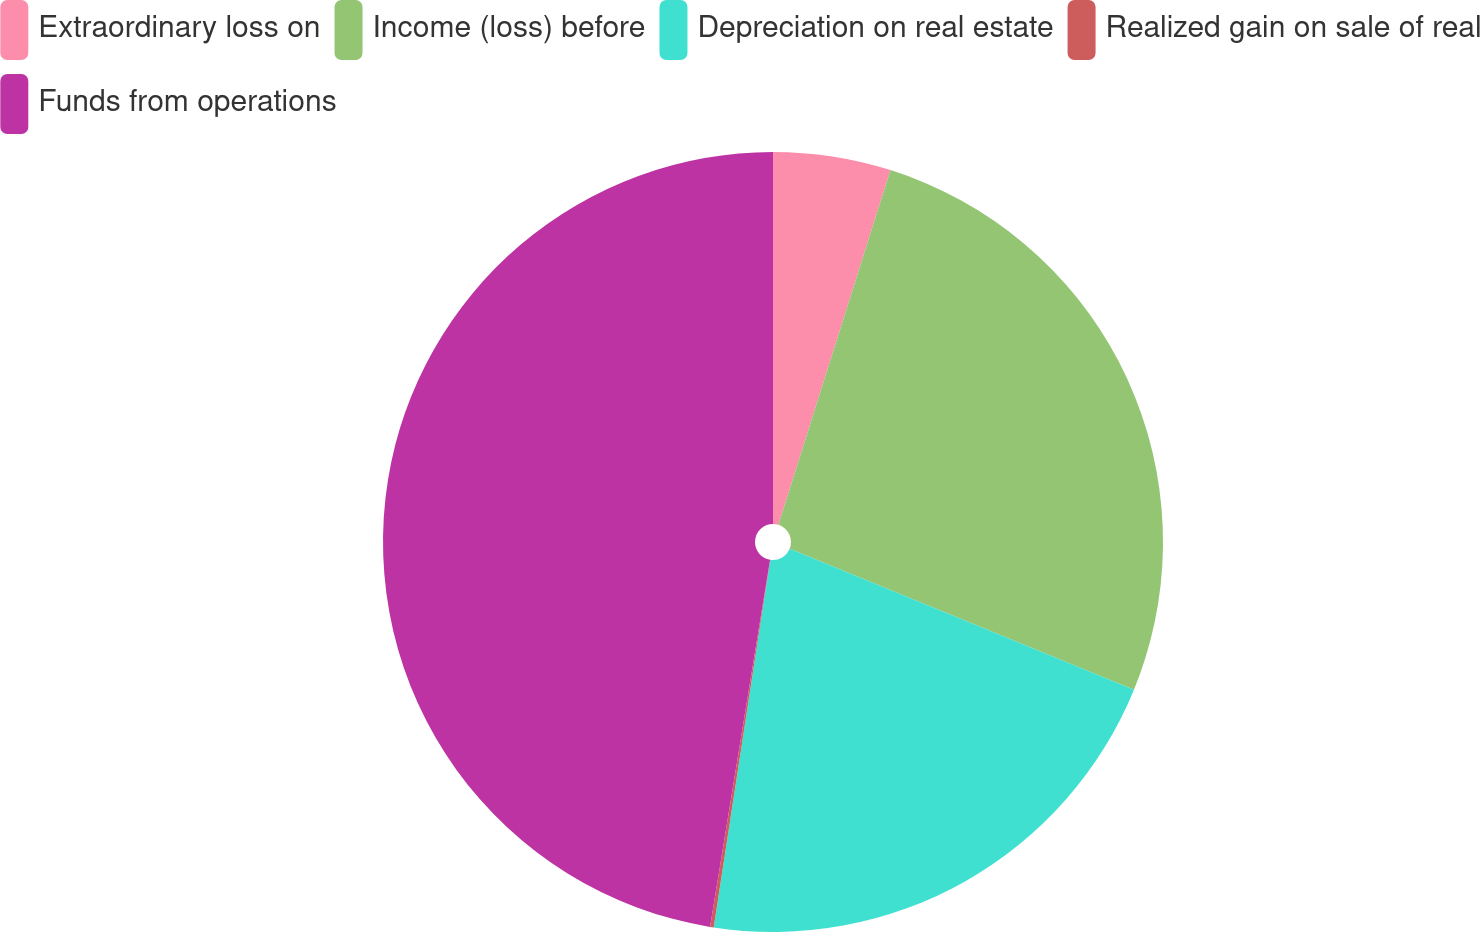<chart> <loc_0><loc_0><loc_500><loc_500><pie_chart><fcel>Extraordinary loss on<fcel>Income (loss) before<fcel>Depreciation on real estate<fcel>Realized gain on sale of real<fcel>Funds from operations<nl><fcel>4.87%<fcel>26.31%<fcel>21.25%<fcel>0.15%<fcel>47.42%<nl></chart> 